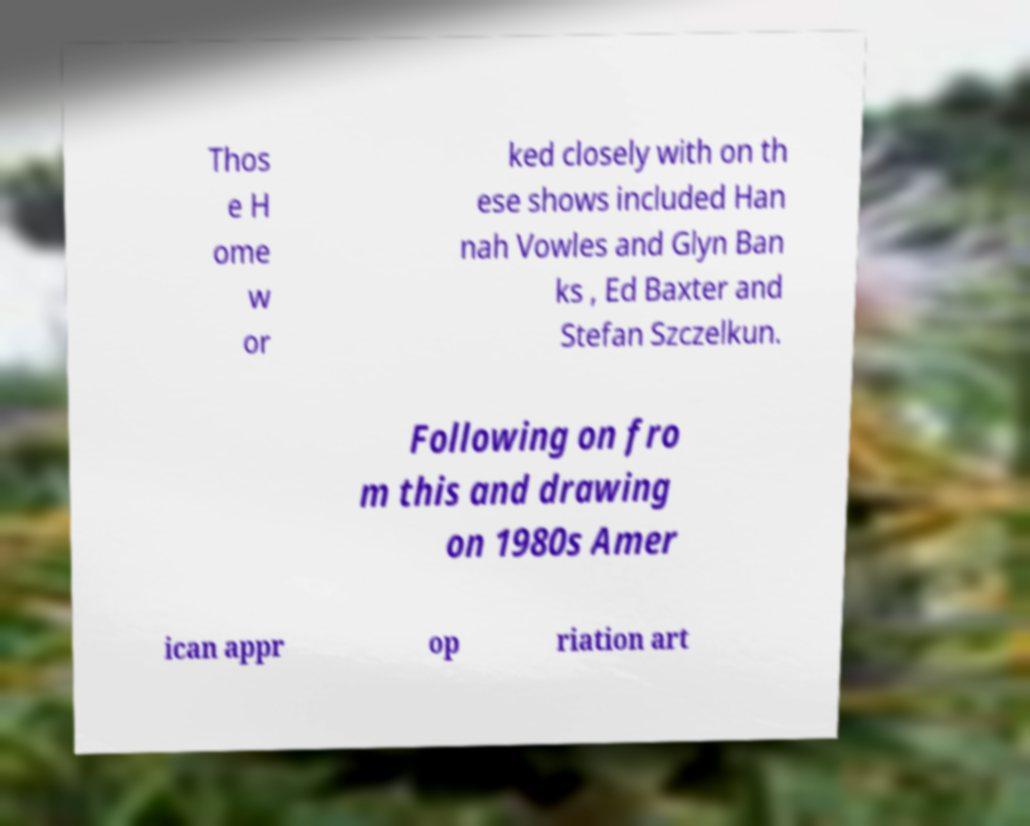There's text embedded in this image that I need extracted. Can you transcribe it verbatim? Thos e H ome w or ked closely with on th ese shows included Han nah Vowles and Glyn Ban ks , Ed Baxter and Stefan Szczelkun. Following on fro m this and drawing on 1980s Amer ican appr op riation art 